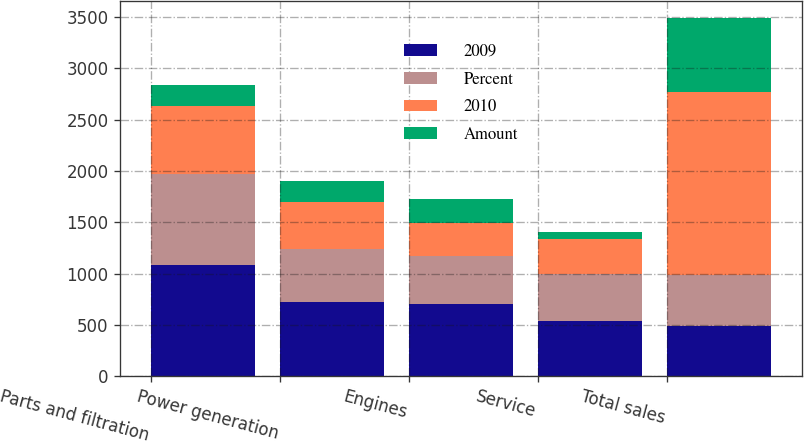<chart> <loc_0><loc_0><loc_500><loc_500><stacked_bar_chart><ecel><fcel>Parts and filtration<fcel>Power generation<fcel>Engines<fcel>Service<fcel>Total sales<nl><fcel>2009<fcel>1085<fcel>722<fcel>703<fcel>534<fcel>491<nl><fcel>Percent<fcel>882<fcel>516<fcel>466<fcel>460<fcel>491<nl><fcel>2010<fcel>665<fcel>457<fcel>324<fcel>338<fcel>1784<nl><fcel>Amount<fcel>203<fcel>206<fcel>237<fcel>74<fcel>720<nl></chart> 